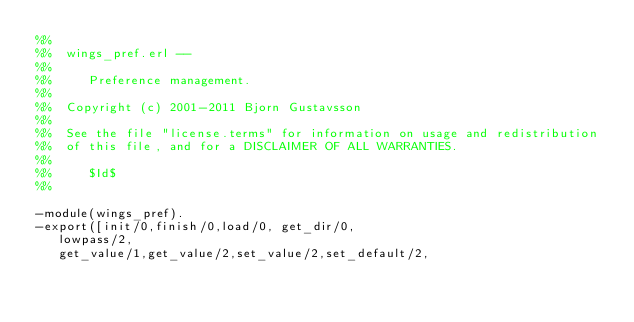<code> <loc_0><loc_0><loc_500><loc_500><_Erlang_>%%
%%  wings_pref.erl --
%%
%%     Preference management.
%%
%%  Copyright (c) 2001-2011 Bjorn Gustavsson
%%
%%  See the file "license.terms" for information on usage and redistribution
%%  of this file, and for a DISCLAIMER OF ALL WARRANTIES.
%%
%%     $Id$
%%

-module(wings_pref).
-export([init/0,finish/0,load/0, get_dir/0,
	 lowpass/2,
	 get_value/1,get_value/2,set_value/2,set_default/2,</code> 